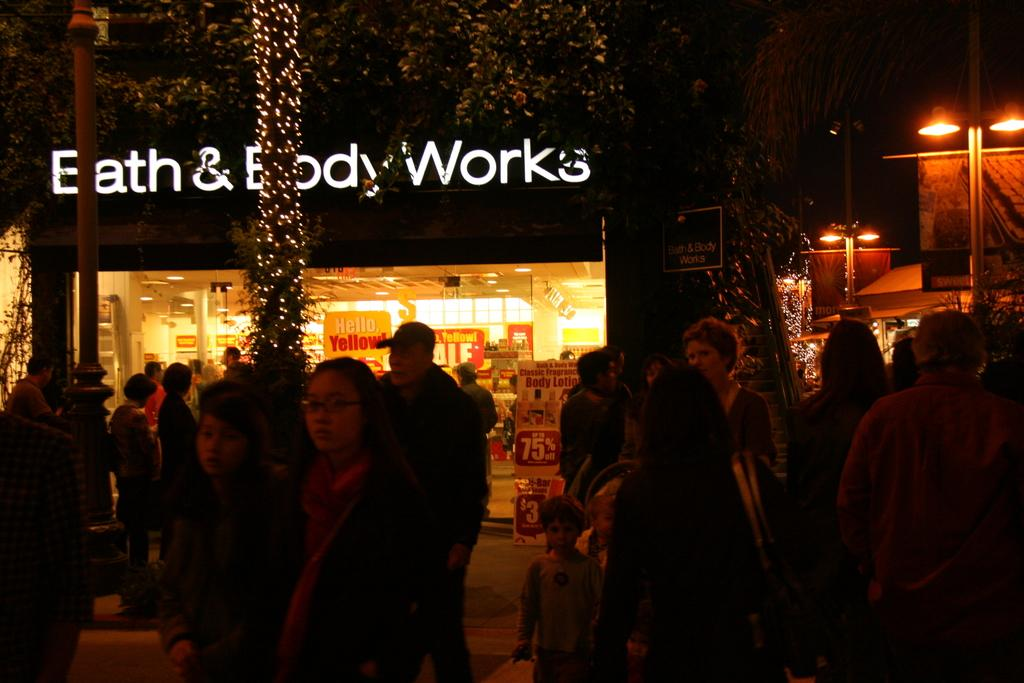Who or what is present in the image? There are people in the image. What type of structures can be seen in the image? There are buildings in the image. What objects are present in the image that might be used for displaying information or advertisements? There are boards in the image. What type of establishment can be seen in the image? There is a store in the image. What type of vertical structures are present in the image? There are poles in the image. What type of illumination is present in the image? There are lights in the image. What type of natural elements are present in the image? There are trees in the image. How many cakes are being sold in the store in the image? There is no information about cakes or any type of food being sold in the store in the image. Can you see an airplane flying in the sky in the image? There is no mention of an airplane or any type of aircraft in the image. 